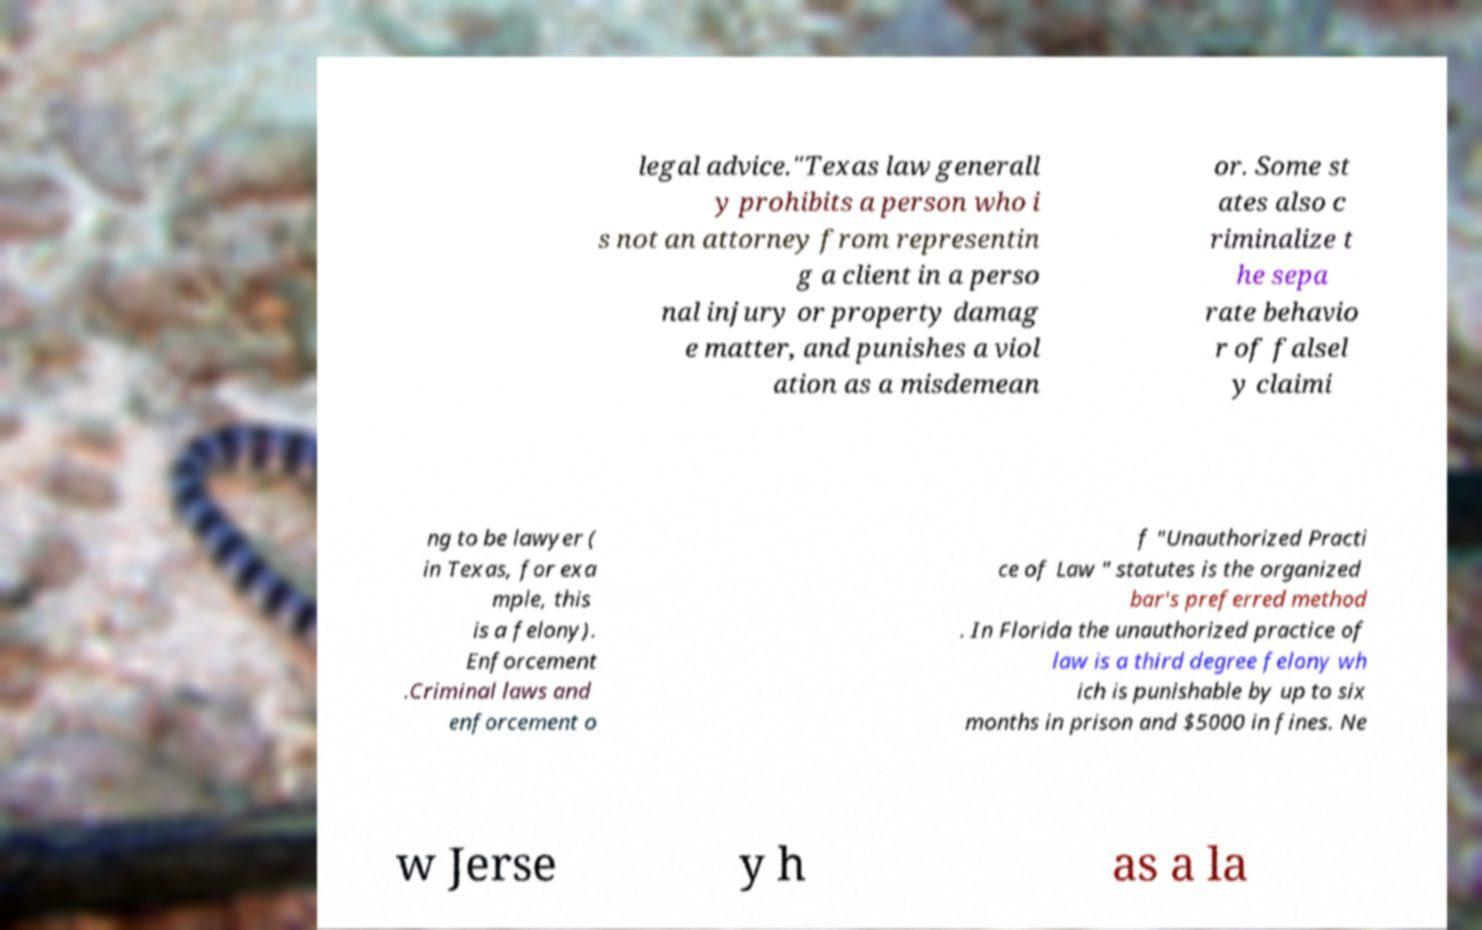For documentation purposes, I need the text within this image transcribed. Could you provide that? legal advice."Texas law generall y prohibits a person who i s not an attorney from representin g a client in a perso nal injury or property damag e matter, and punishes a viol ation as a misdemean or. Some st ates also c riminalize t he sepa rate behavio r of falsel y claimi ng to be lawyer ( in Texas, for exa mple, this is a felony). Enforcement .Criminal laws and enforcement o f "Unauthorized Practi ce of Law " statutes is the organized bar's preferred method . In Florida the unauthorized practice of law is a third degree felony wh ich is punishable by up to six months in prison and $5000 in fines. Ne w Jerse y h as a la 